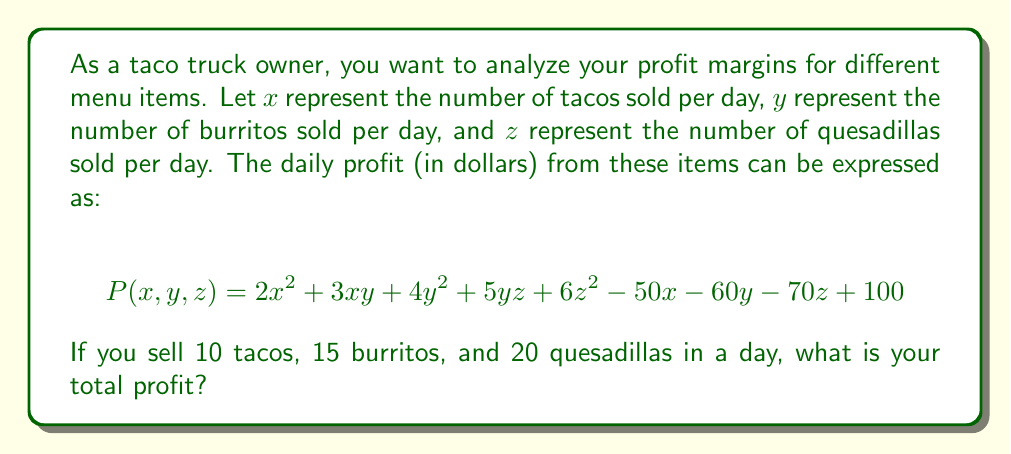What is the answer to this math problem? To solve this problem, we need to substitute the given values into the polynomial expression for profit:

$x = 10$ (tacos)
$y = 15$ (burritos)
$z = 20$ (quesadillas)

Let's substitute these values into the profit function $P(x,y,z)$:

$$\begin{aligned}
P(10,15,20) &= 2(10)^2 + 3(10)(15) + 4(15)^2 + 5(15)(20) + 6(20)^2 - 50(10) - 60(15) - 70(20) + 100 \\[10pt]
&= 2(100) + 3(150) + 4(225) + 5(300) + 6(400) - 500 - 900 - 1400 + 100 \\[10pt]
&= 200 + 450 + 900 + 1500 + 2400 - 500 - 900 - 1400 + 100 \\[10pt]
&= 5450 - 2800 + 100 \\[10pt]
&= 2750
\end{aligned}$$

Therefore, the total profit for selling 10 tacos, 15 burritos, and 20 quesadillas in a day is $2750.
Answer: $2750 